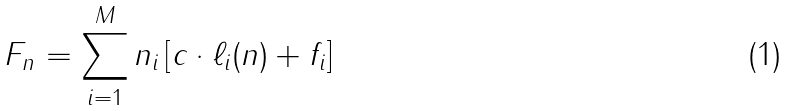Convert formula to latex. <formula><loc_0><loc_0><loc_500><loc_500>F _ { n } = \sum _ { i = 1 } ^ { M } n _ { i } \left [ c \cdot \ell _ { i } ( n ) + f _ { i } \right ]</formula> 